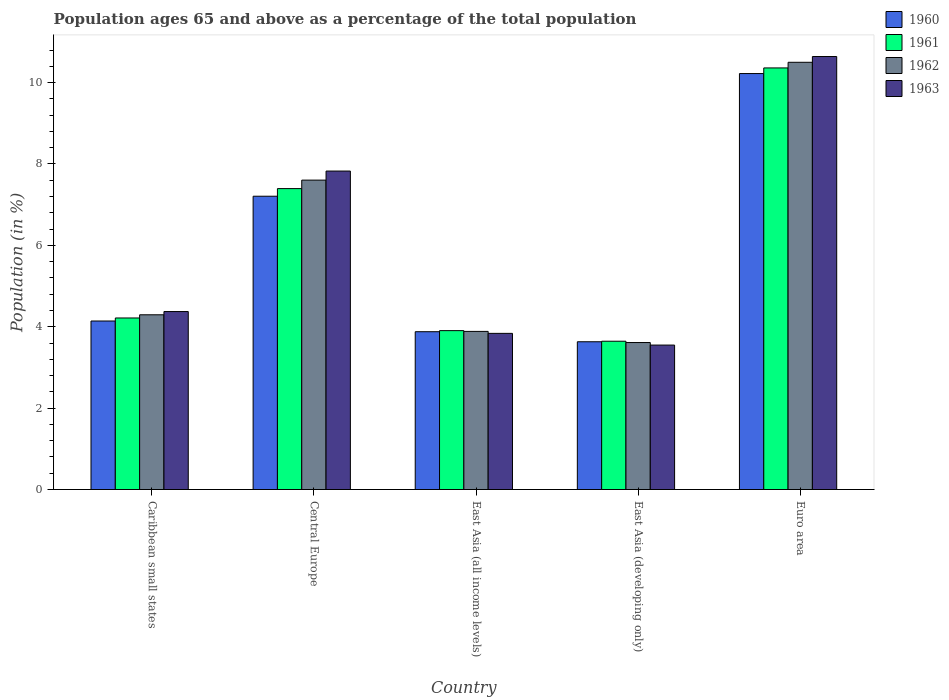How many different coloured bars are there?
Provide a short and direct response. 4. What is the label of the 3rd group of bars from the left?
Your answer should be very brief. East Asia (all income levels). In how many cases, is the number of bars for a given country not equal to the number of legend labels?
Your answer should be compact. 0. What is the percentage of the population ages 65 and above in 1961 in Caribbean small states?
Make the answer very short. 4.22. Across all countries, what is the maximum percentage of the population ages 65 and above in 1963?
Your response must be concise. 10.64. Across all countries, what is the minimum percentage of the population ages 65 and above in 1963?
Ensure brevity in your answer.  3.55. In which country was the percentage of the population ages 65 and above in 1962 minimum?
Give a very brief answer. East Asia (developing only). What is the total percentage of the population ages 65 and above in 1962 in the graph?
Give a very brief answer. 29.9. What is the difference between the percentage of the population ages 65 and above in 1963 in Central Europe and that in East Asia (all income levels)?
Your answer should be very brief. 3.99. What is the difference between the percentage of the population ages 65 and above in 1961 in Euro area and the percentage of the population ages 65 and above in 1963 in Central Europe?
Make the answer very short. 2.53. What is the average percentage of the population ages 65 and above in 1961 per country?
Make the answer very short. 5.9. What is the difference between the percentage of the population ages 65 and above of/in 1963 and percentage of the population ages 65 and above of/in 1960 in East Asia (developing only)?
Keep it short and to the point. -0.08. What is the ratio of the percentage of the population ages 65 and above in 1962 in Caribbean small states to that in Central Europe?
Offer a terse response. 0.56. Is the percentage of the population ages 65 and above in 1962 in Caribbean small states less than that in Euro area?
Keep it short and to the point. Yes. What is the difference between the highest and the second highest percentage of the population ages 65 and above in 1963?
Offer a terse response. 6.27. What is the difference between the highest and the lowest percentage of the population ages 65 and above in 1961?
Your answer should be compact. 6.72. In how many countries, is the percentage of the population ages 65 and above in 1960 greater than the average percentage of the population ages 65 and above in 1960 taken over all countries?
Ensure brevity in your answer.  2. Is the sum of the percentage of the population ages 65 and above in 1960 in Caribbean small states and Central Europe greater than the maximum percentage of the population ages 65 and above in 1962 across all countries?
Your answer should be very brief. Yes. What does the 3rd bar from the left in East Asia (all income levels) represents?
Make the answer very short. 1962. What is the difference between two consecutive major ticks on the Y-axis?
Provide a short and direct response. 2. Are the values on the major ticks of Y-axis written in scientific E-notation?
Give a very brief answer. No. Does the graph contain grids?
Your response must be concise. No. What is the title of the graph?
Offer a terse response. Population ages 65 and above as a percentage of the total population. Does "1985" appear as one of the legend labels in the graph?
Ensure brevity in your answer.  No. What is the Population (in %) in 1960 in Caribbean small states?
Ensure brevity in your answer.  4.14. What is the Population (in %) in 1961 in Caribbean small states?
Your response must be concise. 4.22. What is the Population (in %) of 1962 in Caribbean small states?
Ensure brevity in your answer.  4.29. What is the Population (in %) of 1963 in Caribbean small states?
Your answer should be compact. 4.37. What is the Population (in %) of 1960 in Central Europe?
Make the answer very short. 7.21. What is the Population (in %) in 1961 in Central Europe?
Make the answer very short. 7.4. What is the Population (in %) in 1962 in Central Europe?
Keep it short and to the point. 7.6. What is the Population (in %) of 1963 in Central Europe?
Provide a succinct answer. 7.83. What is the Population (in %) in 1960 in East Asia (all income levels)?
Provide a succinct answer. 3.88. What is the Population (in %) of 1961 in East Asia (all income levels)?
Offer a very short reply. 3.9. What is the Population (in %) in 1962 in East Asia (all income levels)?
Give a very brief answer. 3.89. What is the Population (in %) in 1963 in East Asia (all income levels)?
Offer a terse response. 3.84. What is the Population (in %) of 1960 in East Asia (developing only)?
Your answer should be very brief. 3.63. What is the Population (in %) in 1961 in East Asia (developing only)?
Your response must be concise. 3.64. What is the Population (in %) in 1962 in East Asia (developing only)?
Make the answer very short. 3.61. What is the Population (in %) of 1963 in East Asia (developing only)?
Your answer should be compact. 3.55. What is the Population (in %) of 1960 in Euro area?
Your answer should be compact. 10.22. What is the Population (in %) in 1961 in Euro area?
Your answer should be very brief. 10.36. What is the Population (in %) in 1962 in Euro area?
Offer a terse response. 10.5. What is the Population (in %) in 1963 in Euro area?
Your answer should be compact. 10.64. Across all countries, what is the maximum Population (in %) of 1960?
Make the answer very short. 10.22. Across all countries, what is the maximum Population (in %) in 1961?
Keep it short and to the point. 10.36. Across all countries, what is the maximum Population (in %) in 1962?
Offer a terse response. 10.5. Across all countries, what is the maximum Population (in %) in 1963?
Your answer should be very brief. 10.64. Across all countries, what is the minimum Population (in %) in 1960?
Give a very brief answer. 3.63. Across all countries, what is the minimum Population (in %) of 1961?
Provide a short and direct response. 3.64. Across all countries, what is the minimum Population (in %) of 1962?
Keep it short and to the point. 3.61. Across all countries, what is the minimum Population (in %) in 1963?
Your answer should be compact. 3.55. What is the total Population (in %) of 1960 in the graph?
Offer a terse response. 29.08. What is the total Population (in %) in 1961 in the graph?
Your response must be concise. 29.52. What is the total Population (in %) in 1962 in the graph?
Offer a terse response. 29.9. What is the total Population (in %) of 1963 in the graph?
Your response must be concise. 30.23. What is the difference between the Population (in %) of 1960 in Caribbean small states and that in Central Europe?
Provide a succinct answer. -3.07. What is the difference between the Population (in %) in 1961 in Caribbean small states and that in Central Europe?
Your response must be concise. -3.18. What is the difference between the Population (in %) in 1962 in Caribbean small states and that in Central Europe?
Ensure brevity in your answer.  -3.31. What is the difference between the Population (in %) of 1963 in Caribbean small states and that in Central Europe?
Provide a short and direct response. -3.45. What is the difference between the Population (in %) in 1960 in Caribbean small states and that in East Asia (all income levels)?
Keep it short and to the point. 0.26. What is the difference between the Population (in %) of 1961 in Caribbean small states and that in East Asia (all income levels)?
Offer a terse response. 0.31. What is the difference between the Population (in %) in 1962 in Caribbean small states and that in East Asia (all income levels)?
Provide a short and direct response. 0.41. What is the difference between the Population (in %) of 1963 in Caribbean small states and that in East Asia (all income levels)?
Ensure brevity in your answer.  0.54. What is the difference between the Population (in %) in 1960 in Caribbean small states and that in East Asia (developing only)?
Ensure brevity in your answer.  0.51. What is the difference between the Population (in %) of 1961 in Caribbean small states and that in East Asia (developing only)?
Make the answer very short. 0.57. What is the difference between the Population (in %) in 1962 in Caribbean small states and that in East Asia (developing only)?
Your answer should be very brief. 0.68. What is the difference between the Population (in %) in 1963 in Caribbean small states and that in East Asia (developing only)?
Your answer should be compact. 0.82. What is the difference between the Population (in %) of 1960 in Caribbean small states and that in Euro area?
Offer a very short reply. -6.08. What is the difference between the Population (in %) in 1961 in Caribbean small states and that in Euro area?
Provide a short and direct response. -6.15. What is the difference between the Population (in %) of 1962 in Caribbean small states and that in Euro area?
Make the answer very short. -6.21. What is the difference between the Population (in %) in 1963 in Caribbean small states and that in Euro area?
Your answer should be very brief. -6.27. What is the difference between the Population (in %) of 1960 in Central Europe and that in East Asia (all income levels)?
Your response must be concise. 3.33. What is the difference between the Population (in %) in 1961 in Central Europe and that in East Asia (all income levels)?
Give a very brief answer. 3.49. What is the difference between the Population (in %) of 1962 in Central Europe and that in East Asia (all income levels)?
Provide a succinct answer. 3.72. What is the difference between the Population (in %) in 1963 in Central Europe and that in East Asia (all income levels)?
Keep it short and to the point. 3.99. What is the difference between the Population (in %) of 1960 in Central Europe and that in East Asia (developing only)?
Your response must be concise. 3.58. What is the difference between the Population (in %) in 1961 in Central Europe and that in East Asia (developing only)?
Ensure brevity in your answer.  3.75. What is the difference between the Population (in %) of 1962 in Central Europe and that in East Asia (developing only)?
Your response must be concise. 3.99. What is the difference between the Population (in %) of 1963 in Central Europe and that in East Asia (developing only)?
Keep it short and to the point. 4.28. What is the difference between the Population (in %) in 1960 in Central Europe and that in Euro area?
Your answer should be compact. -3.01. What is the difference between the Population (in %) of 1961 in Central Europe and that in Euro area?
Keep it short and to the point. -2.97. What is the difference between the Population (in %) of 1962 in Central Europe and that in Euro area?
Give a very brief answer. -2.9. What is the difference between the Population (in %) of 1963 in Central Europe and that in Euro area?
Your response must be concise. -2.81. What is the difference between the Population (in %) of 1960 in East Asia (all income levels) and that in East Asia (developing only)?
Keep it short and to the point. 0.25. What is the difference between the Population (in %) in 1961 in East Asia (all income levels) and that in East Asia (developing only)?
Give a very brief answer. 0.26. What is the difference between the Population (in %) in 1962 in East Asia (all income levels) and that in East Asia (developing only)?
Keep it short and to the point. 0.27. What is the difference between the Population (in %) of 1963 in East Asia (all income levels) and that in East Asia (developing only)?
Offer a terse response. 0.29. What is the difference between the Population (in %) of 1960 in East Asia (all income levels) and that in Euro area?
Ensure brevity in your answer.  -6.34. What is the difference between the Population (in %) in 1961 in East Asia (all income levels) and that in Euro area?
Provide a succinct answer. -6.46. What is the difference between the Population (in %) of 1962 in East Asia (all income levels) and that in Euro area?
Your response must be concise. -6.61. What is the difference between the Population (in %) in 1963 in East Asia (all income levels) and that in Euro area?
Keep it short and to the point. -6.8. What is the difference between the Population (in %) of 1960 in East Asia (developing only) and that in Euro area?
Offer a terse response. -6.59. What is the difference between the Population (in %) in 1961 in East Asia (developing only) and that in Euro area?
Offer a terse response. -6.72. What is the difference between the Population (in %) of 1962 in East Asia (developing only) and that in Euro area?
Your answer should be compact. -6.89. What is the difference between the Population (in %) of 1963 in East Asia (developing only) and that in Euro area?
Offer a terse response. -7.09. What is the difference between the Population (in %) in 1960 in Caribbean small states and the Population (in %) in 1961 in Central Europe?
Your answer should be compact. -3.25. What is the difference between the Population (in %) of 1960 in Caribbean small states and the Population (in %) of 1962 in Central Europe?
Offer a very short reply. -3.46. What is the difference between the Population (in %) in 1960 in Caribbean small states and the Population (in %) in 1963 in Central Europe?
Provide a short and direct response. -3.69. What is the difference between the Population (in %) in 1961 in Caribbean small states and the Population (in %) in 1962 in Central Europe?
Offer a terse response. -3.39. What is the difference between the Population (in %) in 1961 in Caribbean small states and the Population (in %) in 1963 in Central Europe?
Offer a very short reply. -3.61. What is the difference between the Population (in %) in 1962 in Caribbean small states and the Population (in %) in 1963 in Central Europe?
Offer a terse response. -3.53. What is the difference between the Population (in %) in 1960 in Caribbean small states and the Population (in %) in 1961 in East Asia (all income levels)?
Your answer should be very brief. 0.24. What is the difference between the Population (in %) of 1960 in Caribbean small states and the Population (in %) of 1962 in East Asia (all income levels)?
Provide a succinct answer. 0.26. What is the difference between the Population (in %) in 1960 in Caribbean small states and the Population (in %) in 1963 in East Asia (all income levels)?
Provide a short and direct response. 0.3. What is the difference between the Population (in %) of 1961 in Caribbean small states and the Population (in %) of 1962 in East Asia (all income levels)?
Provide a succinct answer. 0.33. What is the difference between the Population (in %) of 1961 in Caribbean small states and the Population (in %) of 1963 in East Asia (all income levels)?
Provide a succinct answer. 0.38. What is the difference between the Population (in %) in 1962 in Caribbean small states and the Population (in %) in 1963 in East Asia (all income levels)?
Your response must be concise. 0.46. What is the difference between the Population (in %) of 1960 in Caribbean small states and the Population (in %) of 1961 in East Asia (developing only)?
Keep it short and to the point. 0.5. What is the difference between the Population (in %) of 1960 in Caribbean small states and the Population (in %) of 1962 in East Asia (developing only)?
Offer a terse response. 0.53. What is the difference between the Population (in %) in 1960 in Caribbean small states and the Population (in %) in 1963 in East Asia (developing only)?
Your answer should be very brief. 0.59. What is the difference between the Population (in %) of 1961 in Caribbean small states and the Population (in %) of 1962 in East Asia (developing only)?
Offer a terse response. 0.6. What is the difference between the Population (in %) in 1961 in Caribbean small states and the Population (in %) in 1963 in East Asia (developing only)?
Your response must be concise. 0.67. What is the difference between the Population (in %) of 1962 in Caribbean small states and the Population (in %) of 1963 in East Asia (developing only)?
Your answer should be very brief. 0.74. What is the difference between the Population (in %) of 1960 in Caribbean small states and the Population (in %) of 1961 in Euro area?
Your response must be concise. -6.22. What is the difference between the Population (in %) of 1960 in Caribbean small states and the Population (in %) of 1962 in Euro area?
Your answer should be compact. -6.36. What is the difference between the Population (in %) in 1960 in Caribbean small states and the Population (in %) in 1963 in Euro area?
Give a very brief answer. -6.5. What is the difference between the Population (in %) in 1961 in Caribbean small states and the Population (in %) in 1962 in Euro area?
Offer a terse response. -6.28. What is the difference between the Population (in %) of 1961 in Caribbean small states and the Population (in %) of 1963 in Euro area?
Make the answer very short. -6.43. What is the difference between the Population (in %) in 1962 in Caribbean small states and the Population (in %) in 1963 in Euro area?
Offer a terse response. -6.35. What is the difference between the Population (in %) in 1960 in Central Europe and the Population (in %) in 1961 in East Asia (all income levels)?
Your answer should be compact. 3.3. What is the difference between the Population (in %) in 1960 in Central Europe and the Population (in %) in 1962 in East Asia (all income levels)?
Give a very brief answer. 3.32. What is the difference between the Population (in %) of 1960 in Central Europe and the Population (in %) of 1963 in East Asia (all income levels)?
Keep it short and to the point. 3.37. What is the difference between the Population (in %) in 1961 in Central Europe and the Population (in %) in 1962 in East Asia (all income levels)?
Your response must be concise. 3.51. What is the difference between the Population (in %) of 1961 in Central Europe and the Population (in %) of 1963 in East Asia (all income levels)?
Provide a short and direct response. 3.56. What is the difference between the Population (in %) in 1962 in Central Europe and the Population (in %) in 1963 in East Asia (all income levels)?
Keep it short and to the point. 3.77. What is the difference between the Population (in %) of 1960 in Central Europe and the Population (in %) of 1961 in East Asia (developing only)?
Offer a very short reply. 3.56. What is the difference between the Population (in %) in 1960 in Central Europe and the Population (in %) in 1962 in East Asia (developing only)?
Give a very brief answer. 3.6. What is the difference between the Population (in %) in 1960 in Central Europe and the Population (in %) in 1963 in East Asia (developing only)?
Your answer should be compact. 3.66. What is the difference between the Population (in %) in 1961 in Central Europe and the Population (in %) in 1962 in East Asia (developing only)?
Provide a succinct answer. 3.78. What is the difference between the Population (in %) of 1961 in Central Europe and the Population (in %) of 1963 in East Asia (developing only)?
Provide a short and direct response. 3.85. What is the difference between the Population (in %) in 1962 in Central Europe and the Population (in %) in 1963 in East Asia (developing only)?
Offer a very short reply. 4.05. What is the difference between the Population (in %) in 1960 in Central Europe and the Population (in %) in 1961 in Euro area?
Your answer should be very brief. -3.15. What is the difference between the Population (in %) in 1960 in Central Europe and the Population (in %) in 1962 in Euro area?
Your answer should be compact. -3.29. What is the difference between the Population (in %) of 1960 in Central Europe and the Population (in %) of 1963 in Euro area?
Your response must be concise. -3.43. What is the difference between the Population (in %) of 1961 in Central Europe and the Population (in %) of 1962 in Euro area?
Ensure brevity in your answer.  -3.1. What is the difference between the Population (in %) of 1961 in Central Europe and the Population (in %) of 1963 in Euro area?
Ensure brevity in your answer.  -3.25. What is the difference between the Population (in %) of 1962 in Central Europe and the Population (in %) of 1963 in Euro area?
Your answer should be compact. -3.04. What is the difference between the Population (in %) in 1960 in East Asia (all income levels) and the Population (in %) in 1961 in East Asia (developing only)?
Give a very brief answer. 0.23. What is the difference between the Population (in %) in 1960 in East Asia (all income levels) and the Population (in %) in 1962 in East Asia (developing only)?
Keep it short and to the point. 0.27. What is the difference between the Population (in %) in 1960 in East Asia (all income levels) and the Population (in %) in 1963 in East Asia (developing only)?
Provide a short and direct response. 0.33. What is the difference between the Population (in %) of 1961 in East Asia (all income levels) and the Population (in %) of 1962 in East Asia (developing only)?
Your answer should be very brief. 0.29. What is the difference between the Population (in %) of 1961 in East Asia (all income levels) and the Population (in %) of 1963 in East Asia (developing only)?
Give a very brief answer. 0.35. What is the difference between the Population (in %) in 1962 in East Asia (all income levels) and the Population (in %) in 1963 in East Asia (developing only)?
Your answer should be very brief. 0.34. What is the difference between the Population (in %) of 1960 in East Asia (all income levels) and the Population (in %) of 1961 in Euro area?
Your response must be concise. -6.48. What is the difference between the Population (in %) of 1960 in East Asia (all income levels) and the Population (in %) of 1962 in Euro area?
Provide a short and direct response. -6.62. What is the difference between the Population (in %) in 1960 in East Asia (all income levels) and the Population (in %) in 1963 in Euro area?
Give a very brief answer. -6.76. What is the difference between the Population (in %) of 1961 in East Asia (all income levels) and the Population (in %) of 1962 in Euro area?
Your response must be concise. -6.59. What is the difference between the Population (in %) of 1961 in East Asia (all income levels) and the Population (in %) of 1963 in Euro area?
Provide a short and direct response. -6.74. What is the difference between the Population (in %) in 1962 in East Asia (all income levels) and the Population (in %) in 1963 in Euro area?
Offer a terse response. -6.76. What is the difference between the Population (in %) in 1960 in East Asia (developing only) and the Population (in %) in 1961 in Euro area?
Your answer should be compact. -6.73. What is the difference between the Population (in %) in 1960 in East Asia (developing only) and the Population (in %) in 1962 in Euro area?
Offer a very short reply. -6.87. What is the difference between the Population (in %) in 1960 in East Asia (developing only) and the Population (in %) in 1963 in Euro area?
Your response must be concise. -7.01. What is the difference between the Population (in %) in 1961 in East Asia (developing only) and the Population (in %) in 1962 in Euro area?
Your answer should be very brief. -6.86. What is the difference between the Population (in %) in 1961 in East Asia (developing only) and the Population (in %) in 1963 in Euro area?
Ensure brevity in your answer.  -7. What is the difference between the Population (in %) in 1962 in East Asia (developing only) and the Population (in %) in 1963 in Euro area?
Provide a succinct answer. -7.03. What is the average Population (in %) of 1960 per country?
Your answer should be compact. 5.82. What is the average Population (in %) of 1961 per country?
Your answer should be compact. 5.9. What is the average Population (in %) of 1962 per country?
Provide a succinct answer. 5.98. What is the average Population (in %) of 1963 per country?
Your answer should be very brief. 6.05. What is the difference between the Population (in %) in 1960 and Population (in %) in 1961 in Caribbean small states?
Provide a succinct answer. -0.07. What is the difference between the Population (in %) in 1960 and Population (in %) in 1962 in Caribbean small states?
Provide a succinct answer. -0.15. What is the difference between the Population (in %) of 1960 and Population (in %) of 1963 in Caribbean small states?
Your response must be concise. -0.23. What is the difference between the Population (in %) of 1961 and Population (in %) of 1962 in Caribbean small states?
Offer a terse response. -0.08. What is the difference between the Population (in %) in 1961 and Population (in %) in 1963 in Caribbean small states?
Your response must be concise. -0.16. What is the difference between the Population (in %) in 1962 and Population (in %) in 1963 in Caribbean small states?
Provide a succinct answer. -0.08. What is the difference between the Population (in %) in 1960 and Population (in %) in 1961 in Central Europe?
Provide a short and direct response. -0.19. What is the difference between the Population (in %) in 1960 and Population (in %) in 1962 in Central Europe?
Your answer should be compact. -0.4. What is the difference between the Population (in %) in 1960 and Population (in %) in 1963 in Central Europe?
Offer a terse response. -0.62. What is the difference between the Population (in %) of 1961 and Population (in %) of 1962 in Central Europe?
Keep it short and to the point. -0.21. What is the difference between the Population (in %) in 1961 and Population (in %) in 1963 in Central Europe?
Your answer should be very brief. -0.43. What is the difference between the Population (in %) in 1962 and Population (in %) in 1963 in Central Europe?
Keep it short and to the point. -0.22. What is the difference between the Population (in %) of 1960 and Population (in %) of 1961 in East Asia (all income levels)?
Provide a succinct answer. -0.03. What is the difference between the Population (in %) in 1960 and Population (in %) in 1962 in East Asia (all income levels)?
Your answer should be very brief. -0.01. What is the difference between the Population (in %) in 1960 and Population (in %) in 1963 in East Asia (all income levels)?
Offer a terse response. 0.04. What is the difference between the Population (in %) in 1961 and Population (in %) in 1962 in East Asia (all income levels)?
Offer a very short reply. 0.02. What is the difference between the Population (in %) of 1961 and Population (in %) of 1963 in East Asia (all income levels)?
Provide a short and direct response. 0.07. What is the difference between the Population (in %) of 1962 and Population (in %) of 1963 in East Asia (all income levels)?
Give a very brief answer. 0.05. What is the difference between the Population (in %) of 1960 and Population (in %) of 1961 in East Asia (developing only)?
Your answer should be compact. -0.01. What is the difference between the Population (in %) in 1960 and Population (in %) in 1962 in East Asia (developing only)?
Offer a terse response. 0.02. What is the difference between the Population (in %) of 1960 and Population (in %) of 1963 in East Asia (developing only)?
Offer a terse response. 0.08. What is the difference between the Population (in %) of 1961 and Population (in %) of 1962 in East Asia (developing only)?
Keep it short and to the point. 0.03. What is the difference between the Population (in %) in 1961 and Population (in %) in 1963 in East Asia (developing only)?
Offer a terse response. 0.09. What is the difference between the Population (in %) in 1962 and Population (in %) in 1963 in East Asia (developing only)?
Your response must be concise. 0.06. What is the difference between the Population (in %) in 1960 and Population (in %) in 1961 in Euro area?
Offer a terse response. -0.14. What is the difference between the Population (in %) of 1960 and Population (in %) of 1962 in Euro area?
Keep it short and to the point. -0.28. What is the difference between the Population (in %) of 1960 and Population (in %) of 1963 in Euro area?
Provide a succinct answer. -0.42. What is the difference between the Population (in %) in 1961 and Population (in %) in 1962 in Euro area?
Keep it short and to the point. -0.14. What is the difference between the Population (in %) in 1961 and Population (in %) in 1963 in Euro area?
Your response must be concise. -0.28. What is the difference between the Population (in %) in 1962 and Population (in %) in 1963 in Euro area?
Ensure brevity in your answer.  -0.14. What is the ratio of the Population (in %) in 1960 in Caribbean small states to that in Central Europe?
Make the answer very short. 0.57. What is the ratio of the Population (in %) in 1961 in Caribbean small states to that in Central Europe?
Keep it short and to the point. 0.57. What is the ratio of the Population (in %) of 1962 in Caribbean small states to that in Central Europe?
Offer a very short reply. 0.56. What is the ratio of the Population (in %) of 1963 in Caribbean small states to that in Central Europe?
Give a very brief answer. 0.56. What is the ratio of the Population (in %) in 1960 in Caribbean small states to that in East Asia (all income levels)?
Offer a terse response. 1.07. What is the ratio of the Population (in %) of 1961 in Caribbean small states to that in East Asia (all income levels)?
Give a very brief answer. 1.08. What is the ratio of the Population (in %) in 1962 in Caribbean small states to that in East Asia (all income levels)?
Keep it short and to the point. 1.11. What is the ratio of the Population (in %) of 1963 in Caribbean small states to that in East Asia (all income levels)?
Your answer should be very brief. 1.14. What is the ratio of the Population (in %) of 1960 in Caribbean small states to that in East Asia (developing only)?
Provide a succinct answer. 1.14. What is the ratio of the Population (in %) in 1961 in Caribbean small states to that in East Asia (developing only)?
Ensure brevity in your answer.  1.16. What is the ratio of the Population (in %) in 1962 in Caribbean small states to that in East Asia (developing only)?
Offer a terse response. 1.19. What is the ratio of the Population (in %) of 1963 in Caribbean small states to that in East Asia (developing only)?
Your answer should be compact. 1.23. What is the ratio of the Population (in %) of 1960 in Caribbean small states to that in Euro area?
Your response must be concise. 0.41. What is the ratio of the Population (in %) of 1961 in Caribbean small states to that in Euro area?
Ensure brevity in your answer.  0.41. What is the ratio of the Population (in %) in 1962 in Caribbean small states to that in Euro area?
Keep it short and to the point. 0.41. What is the ratio of the Population (in %) of 1963 in Caribbean small states to that in Euro area?
Offer a terse response. 0.41. What is the ratio of the Population (in %) in 1960 in Central Europe to that in East Asia (all income levels)?
Your response must be concise. 1.86. What is the ratio of the Population (in %) in 1961 in Central Europe to that in East Asia (all income levels)?
Make the answer very short. 1.89. What is the ratio of the Population (in %) in 1962 in Central Europe to that in East Asia (all income levels)?
Offer a very short reply. 1.96. What is the ratio of the Population (in %) in 1963 in Central Europe to that in East Asia (all income levels)?
Give a very brief answer. 2.04. What is the ratio of the Population (in %) of 1960 in Central Europe to that in East Asia (developing only)?
Offer a very short reply. 1.98. What is the ratio of the Population (in %) in 1961 in Central Europe to that in East Asia (developing only)?
Provide a succinct answer. 2.03. What is the ratio of the Population (in %) of 1962 in Central Europe to that in East Asia (developing only)?
Your answer should be very brief. 2.11. What is the ratio of the Population (in %) of 1963 in Central Europe to that in East Asia (developing only)?
Your response must be concise. 2.2. What is the ratio of the Population (in %) in 1960 in Central Europe to that in Euro area?
Give a very brief answer. 0.71. What is the ratio of the Population (in %) of 1961 in Central Europe to that in Euro area?
Your answer should be very brief. 0.71. What is the ratio of the Population (in %) in 1962 in Central Europe to that in Euro area?
Offer a terse response. 0.72. What is the ratio of the Population (in %) of 1963 in Central Europe to that in Euro area?
Ensure brevity in your answer.  0.74. What is the ratio of the Population (in %) of 1960 in East Asia (all income levels) to that in East Asia (developing only)?
Provide a succinct answer. 1.07. What is the ratio of the Population (in %) in 1961 in East Asia (all income levels) to that in East Asia (developing only)?
Offer a terse response. 1.07. What is the ratio of the Population (in %) of 1962 in East Asia (all income levels) to that in East Asia (developing only)?
Make the answer very short. 1.08. What is the ratio of the Population (in %) in 1963 in East Asia (all income levels) to that in East Asia (developing only)?
Give a very brief answer. 1.08. What is the ratio of the Population (in %) in 1960 in East Asia (all income levels) to that in Euro area?
Provide a short and direct response. 0.38. What is the ratio of the Population (in %) in 1961 in East Asia (all income levels) to that in Euro area?
Make the answer very short. 0.38. What is the ratio of the Population (in %) of 1962 in East Asia (all income levels) to that in Euro area?
Your answer should be compact. 0.37. What is the ratio of the Population (in %) in 1963 in East Asia (all income levels) to that in Euro area?
Keep it short and to the point. 0.36. What is the ratio of the Population (in %) in 1960 in East Asia (developing only) to that in Euro area?
Provide a succinct answer. 0.36. What is the ratio of the Population (in %) of 1961 in East Asia (developing only) to that in Euro area?
Your answer should be very brief. 0.35. What is the ratio of the Population (in %) of 1962 in East Asia (developing only) to that in Euro area?
Give a very brief answer. 0.34. What is the ratio of the Population (in %) of 1963 in East Asia (developing only) to that in Euro area?
Offer a very short reply. 0.33. What is the difference between the highest and the second highest Population (in %) in 1960?
Your response must be concise. 3.01. What is the difference between the highest and the second highest Population (in %) in 1961?
Give a very brief answer. 2.97. What is the difference between the highest and the second highest Population (in %) in 1962?
Make the answer very short. 2.9. What is the difference between the highest and the second highest Population (in %) of 1963?
Offer a very short reply. 2.81. What is the difference between the highest and the lowest Population (in %) in 1960?
Offer a terse response. 6.59. What is the difference between the highest and the lowest Population (in %) of 1961?
Your answer should be very brief. 6.72. What is the difference between the highest and the lowest Population (in %) in 1962?
Your response must be concise. 6.89. What is the difference between the highest and the lowest Population (in %) of 1963?
Provide a short and direct response. 7.09. 